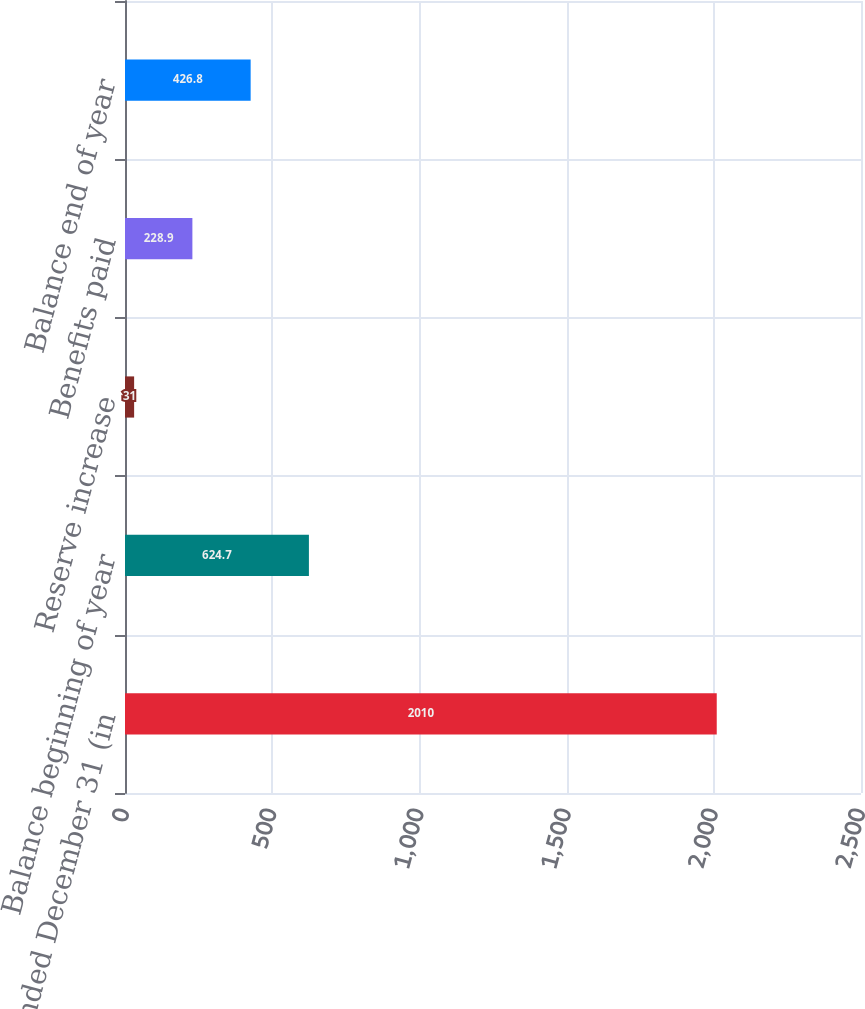Convert chart. <chart><loc_0><loc_0><loc_500><loc_500><bar_chart><fcel>Years Ended December 31 (in<fcel>Balance beginning of year<fcel>Reserve increase<fcel>Benefits paid<fcel>Balance end of year<nl><fcel>2010<fcel>624.7<fcel>31<fcel>228.9<fcel>426.8<nl></chart> 